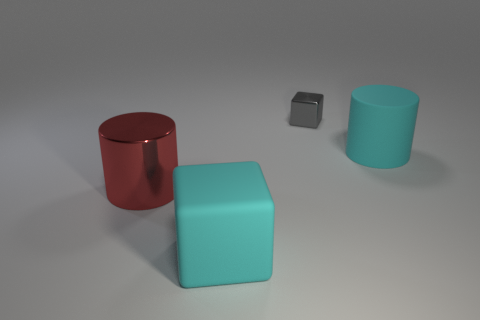Add 2 big cyan rubber cubes. How many objects exist? 6 Add 2 green spheres. How many green spheres exist? 2 Subtract 0 purple spheres. How many objects are left? 4 Subtract all large yellow spheres. Subtract all cyan things. How many objects are left? 2 Add 3 small gray things. How many small gray things are left? 4 